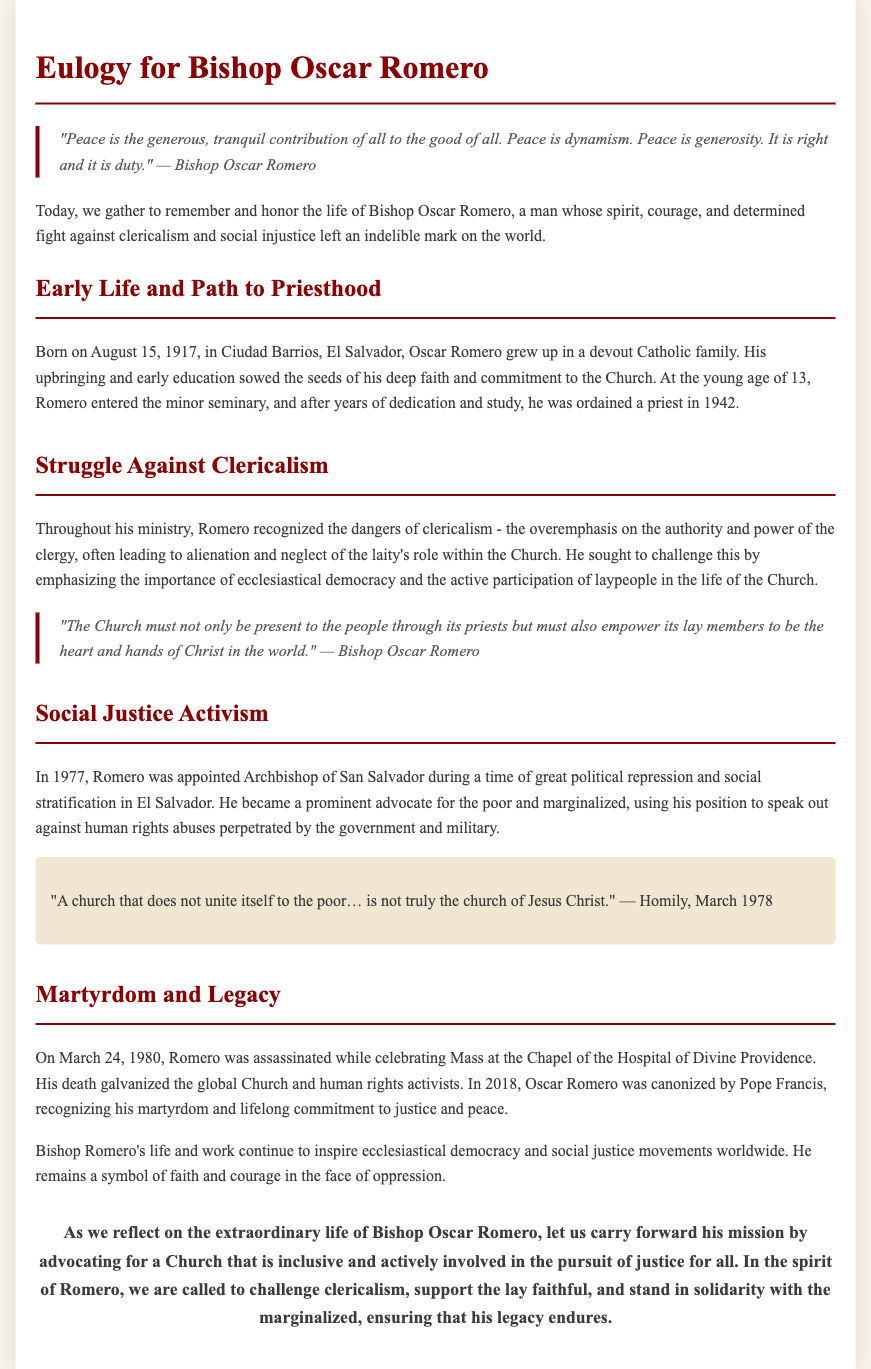What is the birth date of Bishop Oscar Romero? The document states that Bishop Oscar Romero was born on August 15, 1917.
Answer: August 15, 1917 What was Bishop Romero's profession before becoming an Archbishop? The document mentions that he was ordained a priest in 1942 before becoming an Archbishop.
Answer: Priest What year was Romero appointed Archbishop of San Salvador? According to the document, Romero was appointed Archbishop in 1977.
Answer: 1977 What does Bishop Romero emphasize as a priority in the Church? The document highlights that he emphasized the active participation of laypeople in the Church.
Answer: Ecclesiastical democracy In which year was Bishop Oscar Romero canonized? The document states that he was canonized in 2018 by Pope Francis.
Answer: 2018 What does the quote "A church that does not unite itself to the poor… is not truly the church of Jesus Christ." refer to? This quote from Romero’s homily emphasizes the Church's responsibility towards the poor and marginalized.
Answer: Responsibility towards the poor What was the nature of Romero's activism? The document describes him as a prominent advocate for the poor and marginalized during political repression.
Answer: Social justice What encourages participants to remember Romero's mission? The conclusion reflects on the call to challenge clericalism, support the lay faithful, and stand for justice.
Answer: Advocacy for justice What significant event occurred on March 24, 1980, related to Romero? The document mentions that he was assassinated on this date while celebrating Mass.
Answer: Assassination 